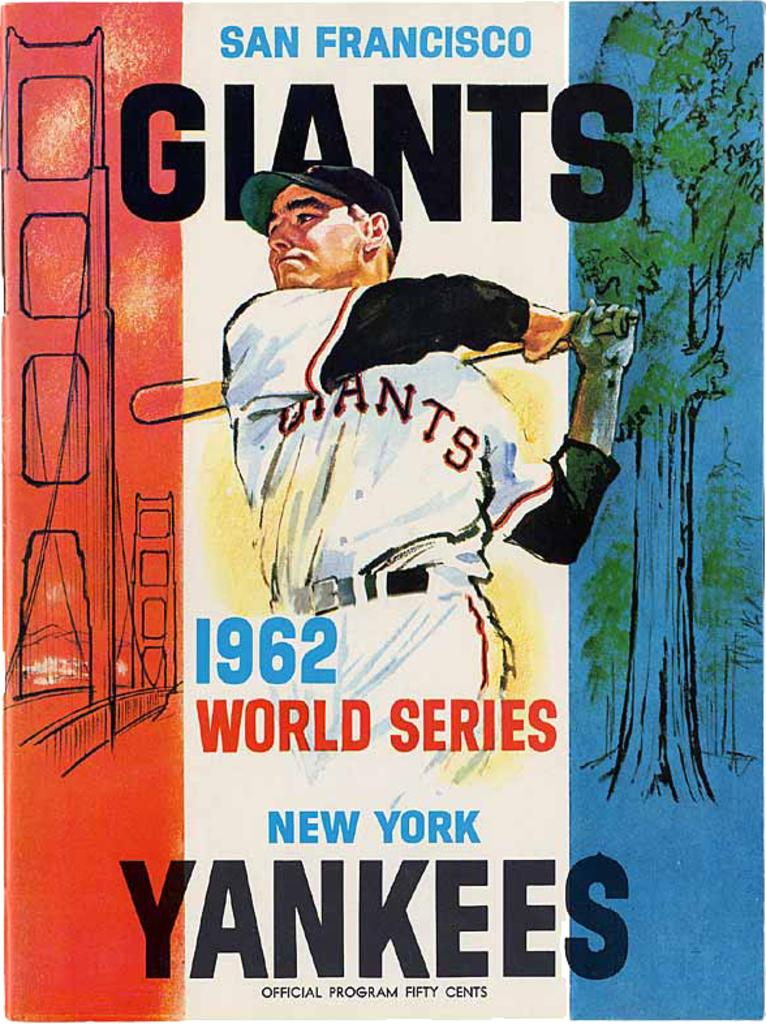<image>
Render a clear and concise summary of the photo. A poster featuring a man with a baseball bat, with the words San Fransicso at the top and Giants just beneath. 